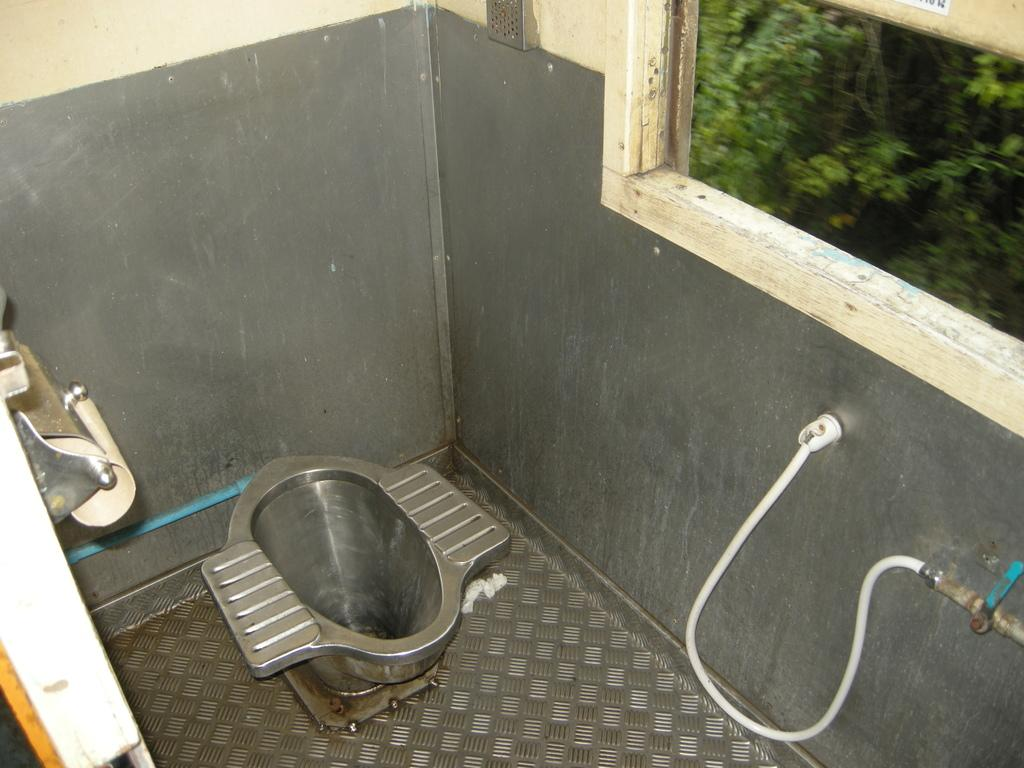What is the main object in the center of the image? There is a toilet seat in the center of the image. What can be seen on the right side of the image? There is a tap and pipe on the right side of the image. What is located on the left side of the image? There is a door on the left side of the image. What is visible in the background of the image? There is a wall and a window visible in the background of the image. What type of eggnog is being served in the image? There is no eggnog present in the image. How does the skate contribute to the functionality of the toilet seat in the image? There is no skate present in the image, and therefore it does not contribute to the functionality of the toilet seat. 